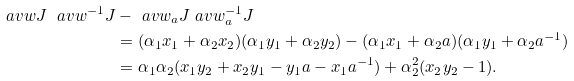Convert formula to latex. <formula><loc_0><loc_0><loc_500><loc_500>\ a v w J \ a v { w ^ { - 1 } } J & - \ a v { w _ { a } } J \ a v { w _ { a } ^ { - 1 } } J \\ & = ( \alpha _ { 1 } x _ { 1 } + \alpha _ { 2 } x _ { 2 } ) ( \alpha _ { 1 } y _ { 1 } + \alpha _ { 2 } y _ { 2 } ) - ( \alpha _ { 1 } x _ { 1 } + \alpha _ { 2 } a ) ( \alpha _ { 1 } y _ { 1 } + \alpha _ { 2 } a ^ { - 1 } ) \\ & = \alpha _ { 1 } \alpha _ { 2 } ( x _ { 1 } y _ { 2 } + x _ { 2 } y _ { 1 } - y _ { 1 } a - x _ { 1 } a ^ { - 1 } ) + \alpha _ { 2 } ^ { 2 } ( x _ { 2 } y _ { 2 } - 1 ) .</formula> 